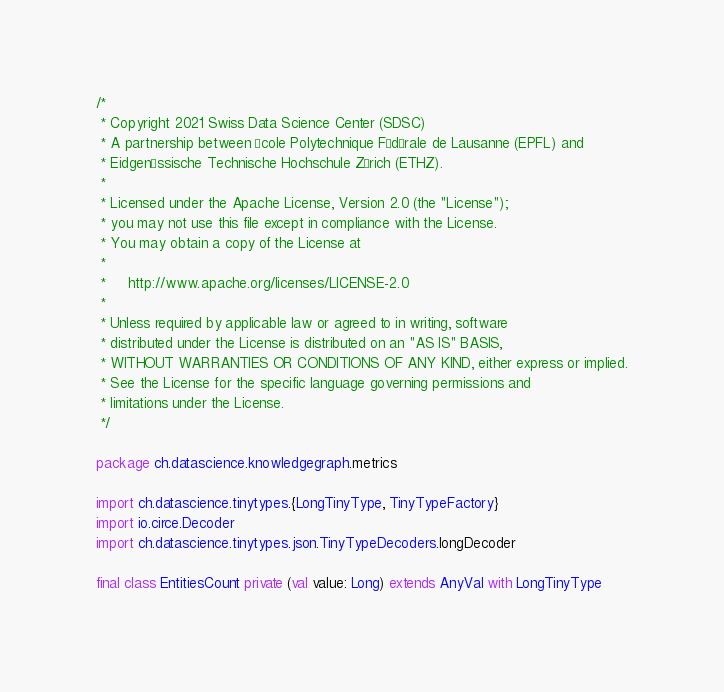<code> <loc_0><loc_0><loc_500><loc_500><_Scala_>/*
 * Copyright 2021 Swiss Data Science Center (SDSC)
 * A partnership between École Polytechnique Fédérale de Lausanne (EPFL) and
 * Eidgenössische Technische Hochschule Zürich (ETHZ).
 *
 * Licensed under the Apache License, Version 2.0 (the "License");
 * you may not use this file except in compliance with the License.
 * You may obtain a copy of the License at
 *
 *     http://www.apache.org/licenses/LICENSE-2.0
 *
 * Unless required by applicable law or agreed to in writing, software
 * distributed under the License is distributed on an "AS IS" BASIS,
 * WITHOUT WARRANTIES OR CONDITIONS OF ANY KIND, either express or implied.
 * See the License for the specific language governing permissions and
 * limitations under the License.
 */

package ch.datascience.knowledgegraph.metrics

import ch.datascience.tinytypes.{LongTinyType, TinyTypeFactory}
import io.circe.Decoder
import ch.datascience.tinytypes.json.TinyTypeDecoders.longDecoder

final class EntitiesCount private (val value: Long) extends AnyVal with LongTinyType</code> 